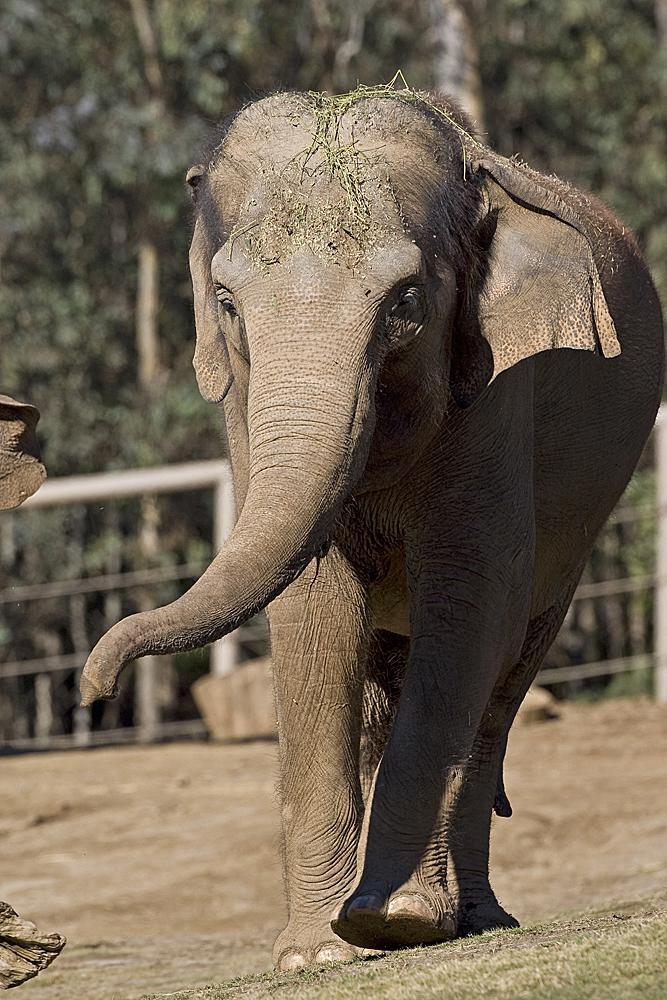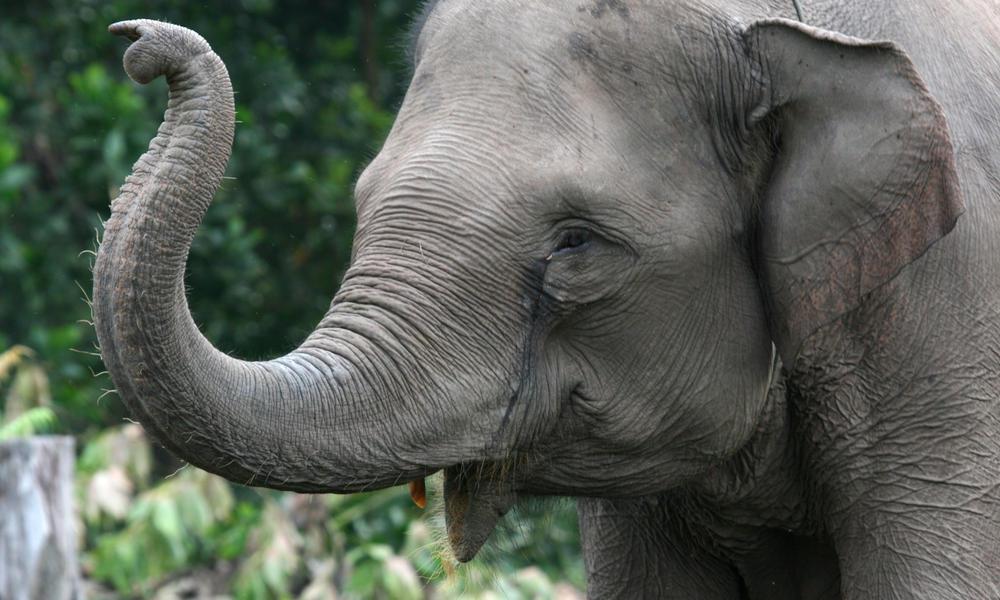The first image is the image on the left, the second image is the image on the right. For the images shown, is this caption "Every image shows exactly one elephant that is outdoors." true? Answer yes or no. Yes. The first image is the image on the left, the second image is the image on the right. Given the left and right images, does the statement "There is at least two elephants in the right image." hold true? Answer yes or no. No. 